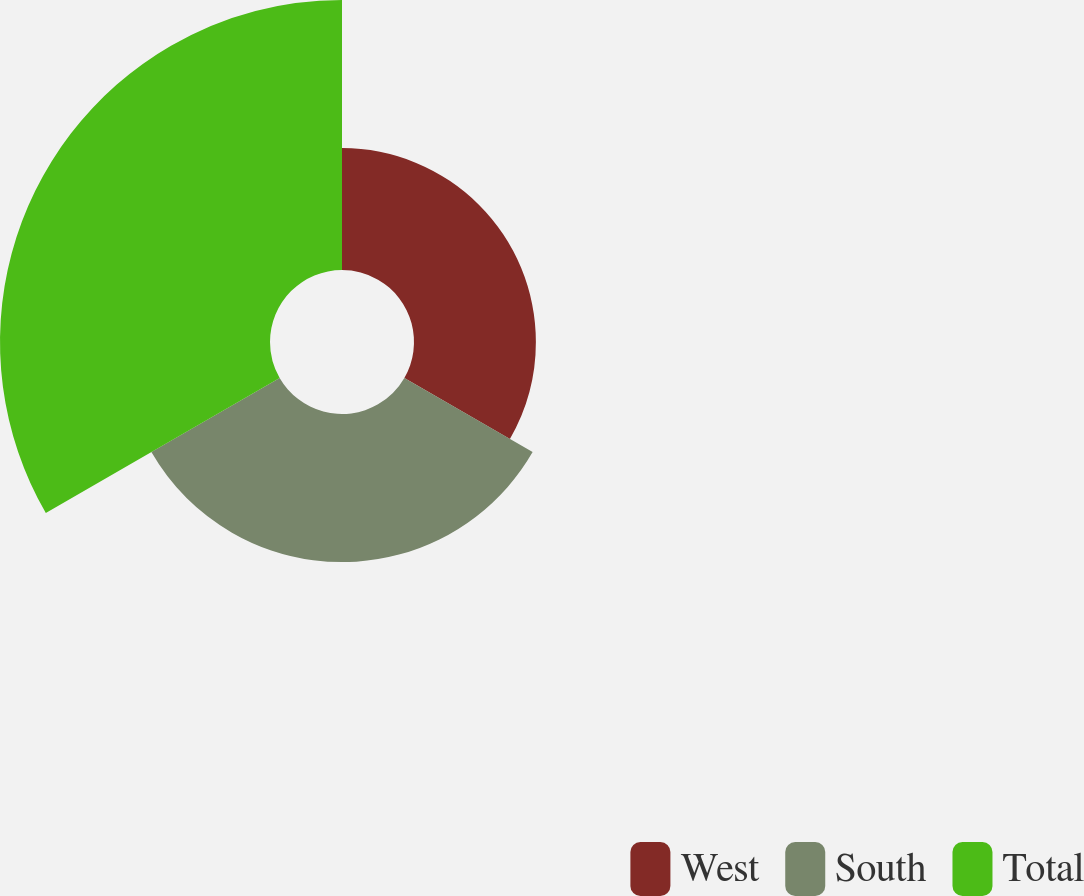Convert chart. <chart><loc_0><loc_0><loc_500><loc_500><pie_chart><fcel>West<fcel>South<fcel>Total<nl><fcel>22.57%<fcel>27.43%<fcel>50.0%<nl></chart> 